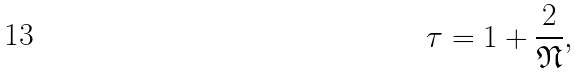Convert formula to latex. <formula><loc_0><loc_0><loc_500><loc_500>\tau = 1 + \frac { 2 } { \mathfrak { N } } ,</formula> 